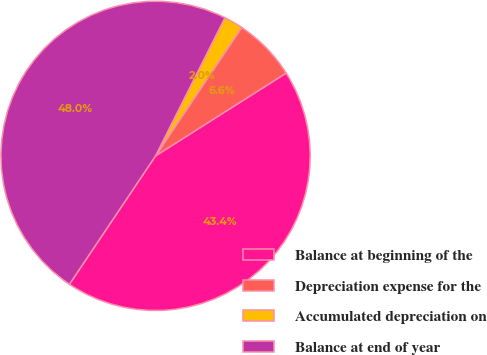Convert chart to OTSL. <chart><loc_0><loc_0><loc_500><loc_500><pie_chart><fcel>Balance at beginning of the<fcel>Depreciation expense for the<fcel>Accumulated depreciation on<fcel>Balance at end of year<nl><fcel>43.4%<fcel>6.6%<fcel>2.0%<fcel>48.0%<nl></chart> 